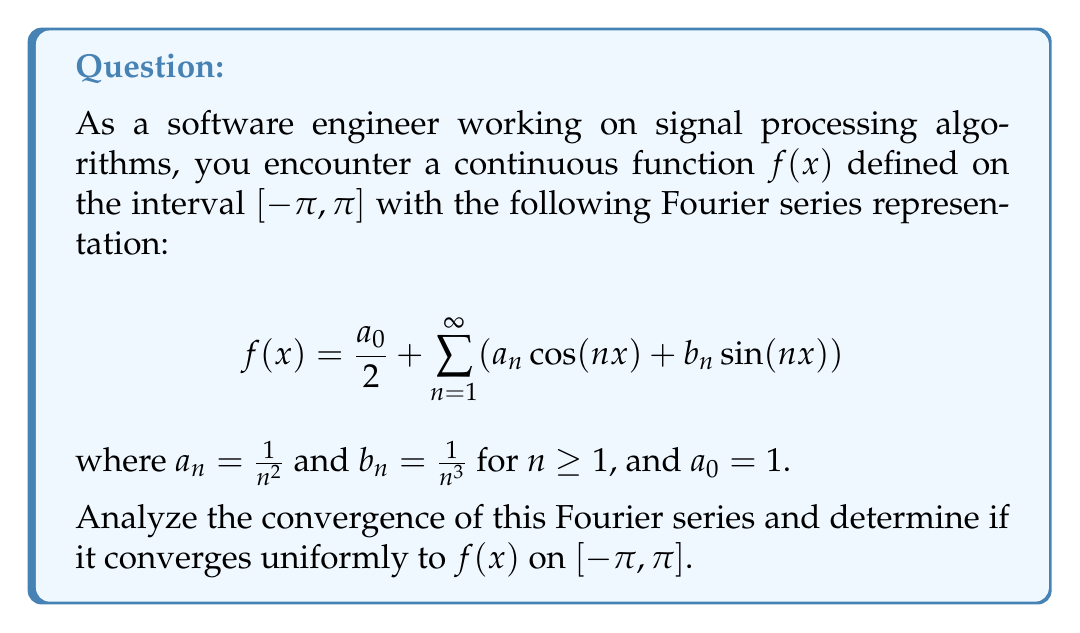Help me with this question. To analyze the convergence of this Fourier series, we'll follow these steps:

1. Check if the coefficients $a_n$ and $b_n$ satisfy the Dirichlet conditions.
2. Verify if the series of coefficients converge absolutely.
3. Apply the Weierstrass M-test to determine uniform convergence.

Step 1: Dirichlet conditions
The Dirichlet conditions are satisfied because:
- $f(x)$ is continuous on $[-\pi, \pi]$
- $f(x)$ has a finite number of maxima and minima in $[-\pi, \pi]$
- $f(x)$ has a finite number of discontinuities in $[-\pi, \pi]$

Step 2: Absolute convergence of coefficients
We need to check if $\sum_{n=1}^{\infty} |a_n| + |b_n|$ converges.

$$\sum_{n=1}^{\infty} |a_n| + |b_n| = \sum_{n=1}^{\infty} \frac{1}{n^2} + \frac{1}{n^3}$$

Both series $\sum_{n=1}^{\infty} \frac{1}{n^2}$ and $\sum_{n=1}^{\infty} \frac{1}{n^3}$ converge by the p-series test (p > 1). Therefore, the series of coefficients converges absolutely.

Step 3: Uniform convergence
To prove uniform convergence, we'll use the Weierstrass M-test. Let's define:

$$M_n = |a_n| + |b_n| = \frac{1}{n^2} + \frac{1}{n^3}$$

We need to show that $\sum_{n=1}^{\infty} M_n$ converges. We've already proven this in Step 2.

Now, we need to show that for all $x \in [-\pi, \pi]$ and for all $n \geq 1$:

$$|a_n \cos(nx) + b_n \sin(nx)| \leq M_n$$

This is true because:

$$|a_n \cos(nx) + b_n \sin(nx)| \leq |a_n| |\cos(nx)| + |b_n| |\sin(nx)| \leq |a_n| + |b_n| = M_n$$

Since all conditions of the Weierstrass M-test are satisfied, the Fourier series converges uniformly on $[-\pi, \pi]$.
Answer: The Fourier series converges uniformly to $f(x)$ on $[-\pi, \pi]$. 